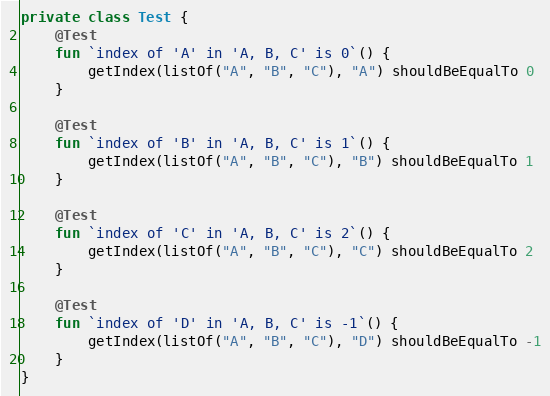Convert code to text. <code><loc_0><loc_0><loc_500><loc_500><_Kotlin_>private class Test {
    @Test
    fun `index of 'A' in 'A, B, C' is 0`() {
        getIndex(listOf("A", "B", "C"), "A") shouldBeEqualTo 0
    }

    @Test
    fun `index of 'B' in 'A, B, C' is 1`() {
        getIndex(listOf("A", "B", "C"), "B") shouldBeEqualTo 1
    }

    @Test
    fun `index of 'C' in 'A, B, C' is 2`() {
        getIndex(listOf("A", "B", "C"), "C") shouldBeEqualTo 2
    }

    @Test
    fun `index of 'D' in 'A, B, C' is -1`() {
        getIndex(listOf("A", "B", "C"), "D") shouldBeEqualTo -1
    }
}
</code> 